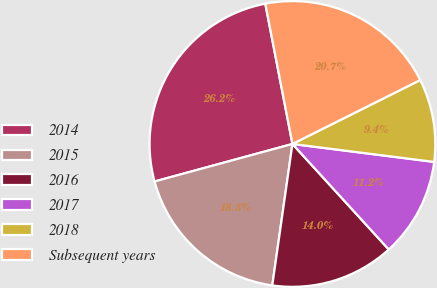Convert chart to OTSL. <chart><loc_0><loc_0><loc_500><loc_500><pie_chart><fcel>2014<fcel>2015<fcel>2016<fcel>2017<fcel>2018<fcel>Subsequent years<nl><fcel>26.19%<fcel>18.52%<fcel>14.03%<fcel>11.22%<fcel>9.39%<fcel>20.66%<nl></chart> 